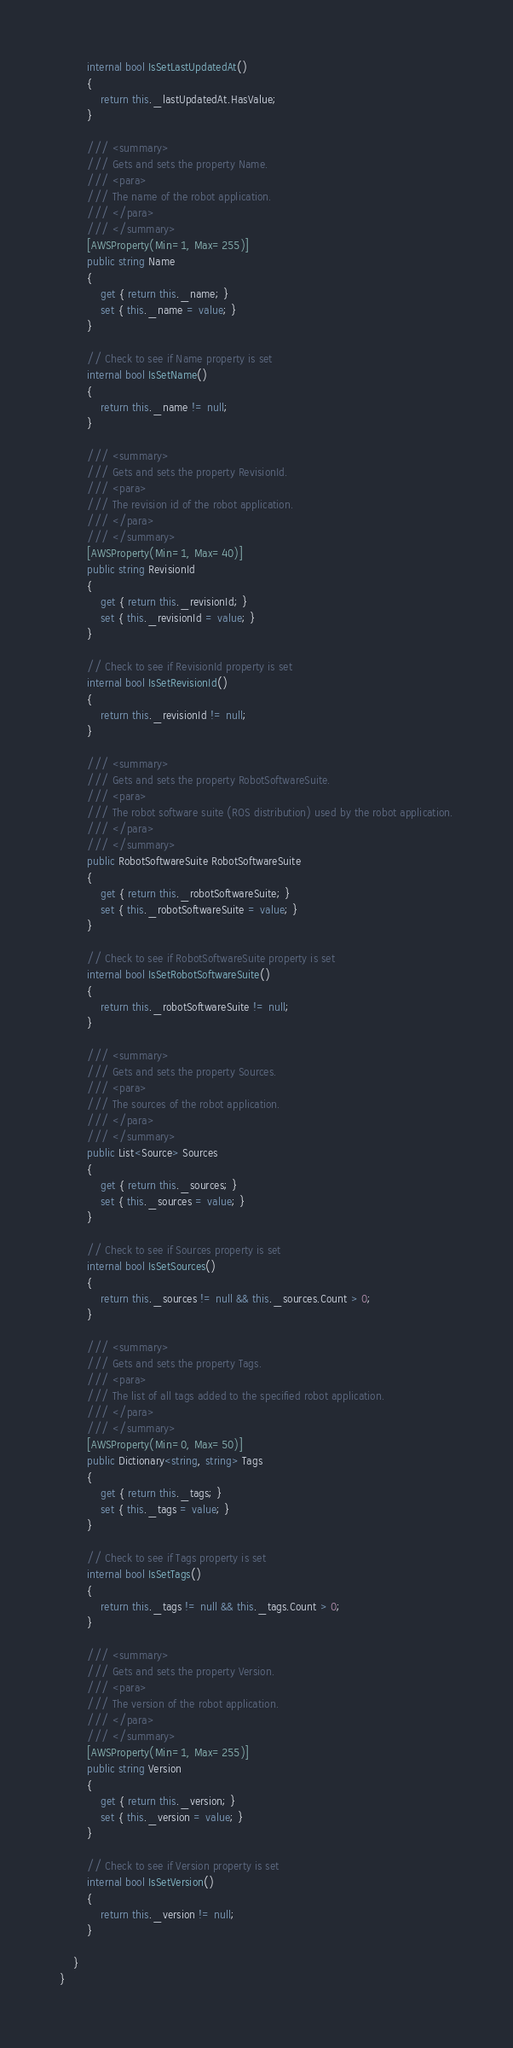Convert code to text. <code><loc_0><loc_0><loc_500><loc_500><_C#_>        internal bool IsSetLastUpdatedAt()
        {
            return this._lastUpdatedAt.HasValue; 
        }

        /// <summary>
        /// Gets and sets the property Name. 
        /// <para>
        /// The name of the robot application.
        /// </para>
        /// </summary>
        [AWSProperty(Min=1, Max=255)]
        public string Name
        {
            get { return this._name; }
            set { this._name = value; }
        }

        // Check to see if Name property is set
        internal bool IsSetName()
        {
            return this._name != null;
        }

        /// <summary>
        /// Gets and sets the property RevisionId. 
        /// <para>
        /// The revision id of the robot application.
        /// </para>
        /// </summary>
        [AWSProperty(Min=1, Max=40)]
        public string RevisionId
        {
            get { return this._revisionId; }
            set { this._revisionId = value; }
        }

        // Check to see if RevisionId property is set
        internal bool IsSetRevisionId()
        {
            return this._revisionId != null;
        }

        /// <summary>
        /// Gets and sets the property RobotSoftwareSuite. 
        /// <para>
        /// The robot software suite (ROS distribution) used by the robot application.
        /// </para>
        /// </summary>
        public RobotSoftwareSuite RobotSoftwareSuite
        {
            get { return this._robotSoftwareSuite; }
            set { this._robotSoftwareSuite = value; }
        }

        // Check to see if RobotSoftwareSuite property is set
        internal bool IsSetRobotSoftwareSuite()
        {
            return this._robotSoftwareSuite != null;
        }

        /// <summary>
        /// Gets and sets the property Sources. 
        /// <para>
        /// The sources of the robot application.
        /// </para>
        /// </summary>
        public List<Source> Sources
        {
            get { return this._sources; }
            set { this._sources = value; }
        }

        // Check to see if Sources property is set
        internal bool IsSetSources()
        {
            return this._sources != null && this._sources.Count > 0; 
        }

        /// <summary>
        /// Gets and sets the property Tags. 
        /// <para>
        /// The list of all tags added to the specified robot application.
        /// </para>
        /// </summary>
        [AWSProperty(Min=0, Max=50)]
        public Dictionary<string, string> Tags
        {
            get { return this._tags; }
            set { this._tags = value; }
        }

        // Check to see if Tags property is set
        internal bool IsSetTags()
        {
            return this._tags != null && this._tags.Count > 0; 
        }

        /// <summary>
        /// Gets and sets the property Version. 
        /// <para>
        /// The version of the robot application.
        /// </para>
        /// </summary>
        [AWSProperty(Min=1, Max=255)]
        public string Version
        {
            get { return this._version; }
            set { this._version = value; }
        }

        // Check to see if Version property is set
        internal bool IsSetVersion()
        {
            return this._version != null;
        }

    }
}</code> 